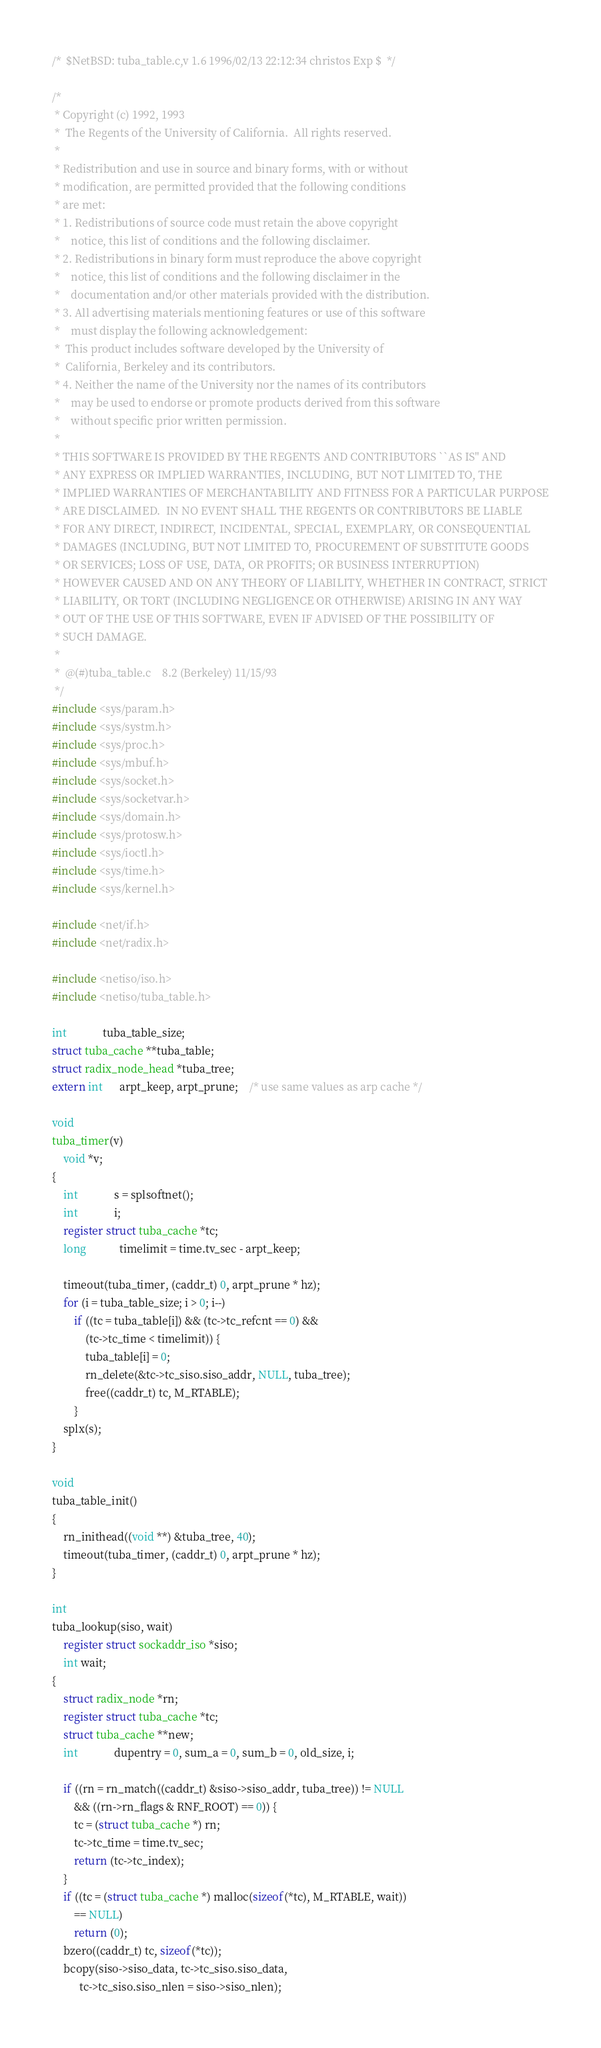<code> <loc_0><loc_0><loc_500><loc_500><_C_>/*	$NetBSD: tuba_table.c,v 1.6 1996/02/13 22:12:34 christos Exp $	*/

/*
 * Copyright (c) 1992, 1993
 *	The Regents of the University of California.  All rights reserved.
 *
 * Redistribution and use in source and binary forms, with or without
 * modification, are permitted provided that the following conditions
 * are met:
 * 1. Redistributions of source code must retain the above copyright
 *    notice, this list of conditions and the following disclaimer.
 * 2. Redistributions in binary form must reproduce the above copyright
 *    notice, this list of conditions and the following disclaimer in the
 *    documentation and/or other materials provided with the distribution.
 * 3. All advertising materials mentioning features or use of this software
 *    must display the following acknowledgement:
 *	This product includes software developed by the University of
 *	California, Berkeley and its contributors.
 * 4. Neither the name of the University nor the names of its contributors
 *    may be used to endorse or promote products derived from this software
 *    without specific prior written permission.
 *
 * THIS SOFTWARE IS PROVIDED BY THE REGENTS AND CONTRIBUTORS ``AS IS'' AND
 * ANY EXPRESS OR IMPLIED WARRANTIES, INCLUDING, BUT NOT LIMITED TO, THE
 * IMPLIED WARRANTIES OF MERCHANTABILITY AND FITNESS FOR A PARTICULAR PURPOSE
 * ARE DISCLAIMED.  IN NO EVENT SHALL THE REGENTS OR CONTRIBUTORS BE LIABLE
 * FOR ANY DIRECT, INDIRECT, INCIDENTAL, SPECIAL, EXEMPLARY, OR CONSEQUENTIAL
 * DAMAGES (INCLUDING, BUT NOT LIMITED TO, PROCUREMENT OF SUBSTITUTE GOODS
 * OR SERVICES; LOSS OF USE, DATA, OR PROFITS; OR BUSINESS INTERRUPTION)
 * HOWEVER CAUSED AND ON ANY THEORY OF LIABILITY, WHETHER IN CONTRACT, STRICT
 * LIABILITY, OR TORT (INCLUDING NEGLIGENCE OR OTHERWISE) ARISING IN ANY WAY
 * OUT OF THE USE OF THIS SOFTWARE, EVEN IF ADVISED OF THE POSSIBILITY OF
 * SUCH DAMAGE.
 *
 *	@(#)tuba_table.c	8.2 (Berkeley) 11/15/93
 */
#include <sys/param.h>
#include <sys/systm.h>
#include <sys/proc.h>
#include <sys/mbuf.h>
#include <sys/socket.h>
#include <sys/socketvar.h>
#include <sys/domain.h>
#include <sys/protosw.h>
#include <sys/ioctl.h>
#include <sys/time.h>
#include <sys/kernel.h>

#include <net/if.h>
#include <net/radix.h>

#include <netiso/iso.h>
#include <netiso/tuba_table.h>

int             tuba_table_size;
struct tuba_cache **tuba_table;
struct radix_node_head *tuba_tree;
extern int      arpt_keep, arpt_prune;	/* use same values as arp cache */

void
tuba_timer(v)
	void *v;
{
	int             s = splsoftnet();
	int             i;
	register struct tuba_cache *tc;
	long            timelimit = time.tv_sec - arpt_keep;

	timeout(tuba_timer, (caddr_t) 0, arpt_prune * hz);
	for (i = tuba_table_size; i > 0; i--)
		if ((tc = tuba_table[i]) && (tc->tc_refcnt == 0) &&
		    (tc->tc_time < timelimit)) {
			tuba_table[i] = 0;
			rn_delete(&tc->tc_siso.siso_addr, NULL, tuba_tree);
			free((caddr_t) tc, M_RTABLE);
		}
	splx(s);
}

void
tuba_table_init()
{
	rn_inithead((void **) &tuba_tree, 40);
	timeout(tuba_timer, (caddr_t) 0, arpt_prune * hz);
}

int
tuba_lookup(siso, wait)
	register struct sockaddr_iso *siso;
	int wait;
{
	struct radix_node *rn;
	register struct tuba_cache *tc;
	struct tuba_cache **new;
	int             dupentry = 0, sum_a = 0, sum_b = 0, old_size, i;

	if ((rn = rn_match((caddr_t) &siso->siso_addr, tuba_tree)) != NULL
	    && ((rn->rn_flags & RNF_ROOT) == 0)) {
		tc = (struct tuba_cache *) rn;
		tc->tc_time = time.tv_sec;
		return (tc->tc_index);
	}
	if ((tc = (struct tuba_cache *) malloc(sizeof(*tc), M_RTABLE, wait))
	    == NULL)
		return (0);
	bzero((caddr_t) tc, sizeof(*tc));
	bcopy(siso->siso_data, tc->tc_siso.siso_data,
	      tc->tc_siso.siso_nlen = siso->siso_nlen);</code> 